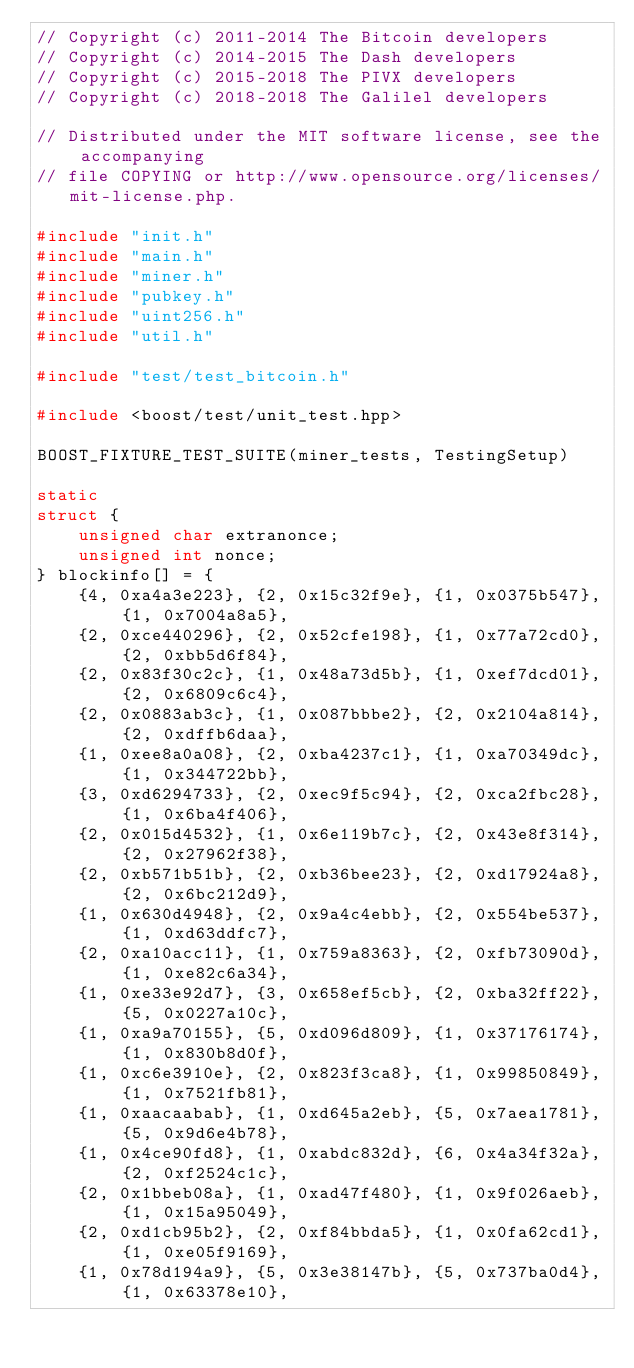<code> <loc_0><loc_0><loc_500><loc_500><_C++_>// Copyright (c) 2011-2014 The Bitcoin developers
// Copyright (c) 2014-2015 The Dash developers
// Copyright (c) 2015-2018 The PIVX developers
// Copyright (c) 2018-2018 The Galilel developers

// Distributed under the MIT software license, see the accompanying
// file COPYING or http://www.opensource.org/licenses/mit-license.php.

#include "init.h"
#include "main.h"
#include "miner.h"
#include "pubkey.h"
#include "uint256.h"
#include "util.h"

#include "test/test_bitcoin.h"

#include <boost/test/unit_test.hpp>

BOOST_FIXTURE_TEST_SUITE(miner_tests, TestingSetup)

static
struct {
    unsigned char extranonce;
    unsigned int nonce;
} blockinfo[] = {
    {4, 0xa4a3e223}, {2, 0x15c32f9e}, {1, 0x0375b547}, {1, 0x7004a8a5},
    {2, 0xce440296}, {2, 0x52cfe198}, {1, 0x77a72cd0}, {2, 0xbb5d6f84},
    {2, 0x83f30c2c}, {1, 0x48a73d5b}, {1, 0xef7dcd01}, {2, 0x6809c6c4},
    {2, 0x0883ab3c}, {1, 0x087bbbe2}, {2, 0x2104a814}, {2, 0xdffb6daa},
    {1, 0xee8a0a08}, {2, 0xba4237c1}, {1, 0xa70349dc}, {1, 0x344722bb},
    {3, 0xd6294733}, {2, 0xec9f5c94}, {2, 0xca2fbc28}, {1, 0x6ba4f406},
    {2, 0x015d4532}, {1, 0x6e119b7c}, {2, 0x43e8f314}, {2, 0x27962f38},
    {2, 0xb571b51b}, {2, 0xb36bee23}, {2, 0xd17924a8}, {2, 0x6bc212d9},
    {1, 0x630d4948}, {2, 0x9a4c4ebb}, {2, 0x554be537}, {1, 0xd63ddfc7},
    {2, 0xa10acc11}, {1, 0x759a8363}, {2, 0xfb73090d}, {1, 0xe82c6a34},
    {1, 0xe33e92d7}, {3, 0x658ef5cb}, {2, 0xba32ff22}, {5, 0x0227a10c},
    {1, 0xa9a70155}, {5, 0xd096d809}, {1, 0x37176174}, {1, 0x830b8d0f},
    {1, 0xc6e3910e}, {2, 0x823f3ca8}, {1, 0x99850849}, {1, 0x7521fb81},
    {1, 0xaacaabab}, {1, 0xd645a2eb}, {5, 0x7aea1781}, {5, 0x9d6e4b78},
    {1, 0x4ce90fd8}, {1, 0xabdc832d}, {6, 0x4a34f32a}, {2, 0xf2524c1c},
    {2, 0x1bbeb08a}, {1, 0xad47f480}, {1, 0x9f026aeb}, {1, 0x15a95049},
    {2, 0xd1cb95b2}, {2, 0xf84bbda5}, {1, 0x0fa62cd1}, {1, 0xe05f9169},
    {1, 0x78d194a9}, {5, 0x3e38147b}, {5, 0x737ba0d4}, {1, 0x63378e10},</code> 